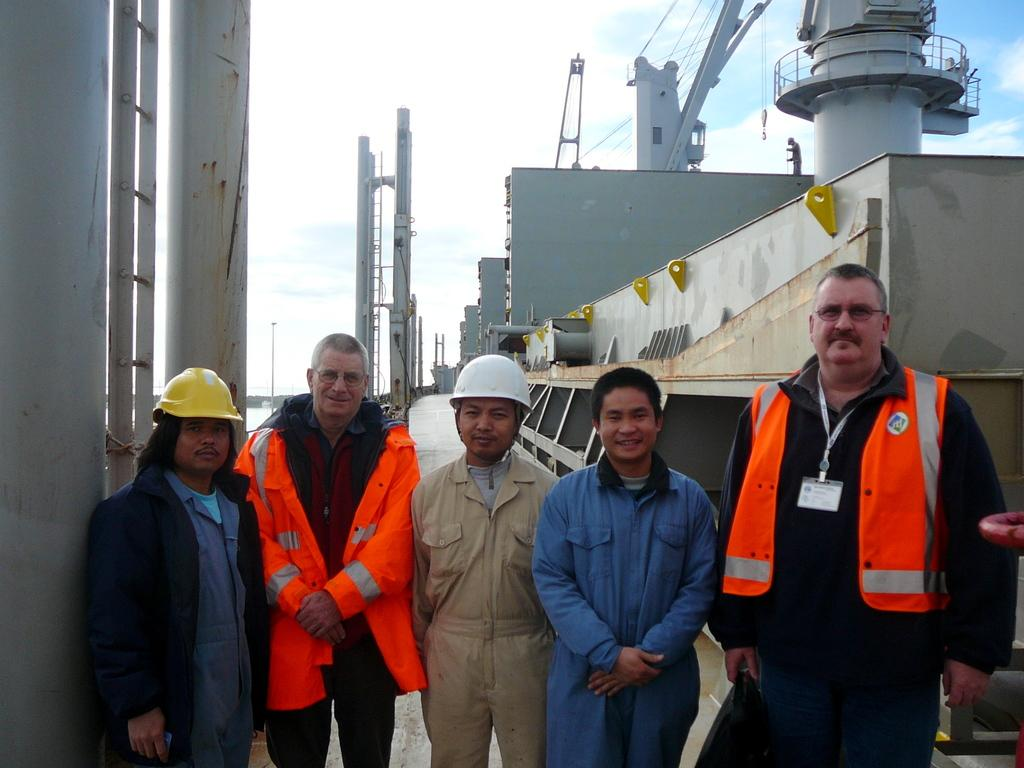How many people are present in the image? There are five people standing in the image. What type of clothing are some of the people wearing? Some of the people are wearing jackets and helmets. What architectural features can be seen in the image? There are pillars, ladders, and walls visible in the image. What can be seen in the background of the image? The sky is visible in the background of the image. What type of brass instrument is being played by the brother in the image? There is no brother or brass instrument present in the image. 